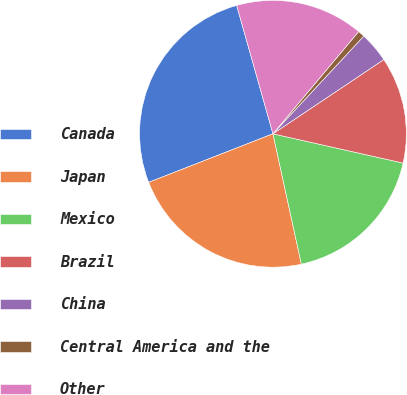Convert chart to OTSL. <chart><loc_0><loc_0><loc_500><loc_500><pie_chart><fcel>Canada<fcel>Japan<fcel>Mexico<fcel>Brazil<fcel>China<fcel>Central America and the<fcel>Other<nl><fcel>26.54%<fcel>22.49%<fcel>18.06%<fcel>12.91%<fcel>3.69%<fcel>0.82%<fcel>15.48%<nl></chart> 